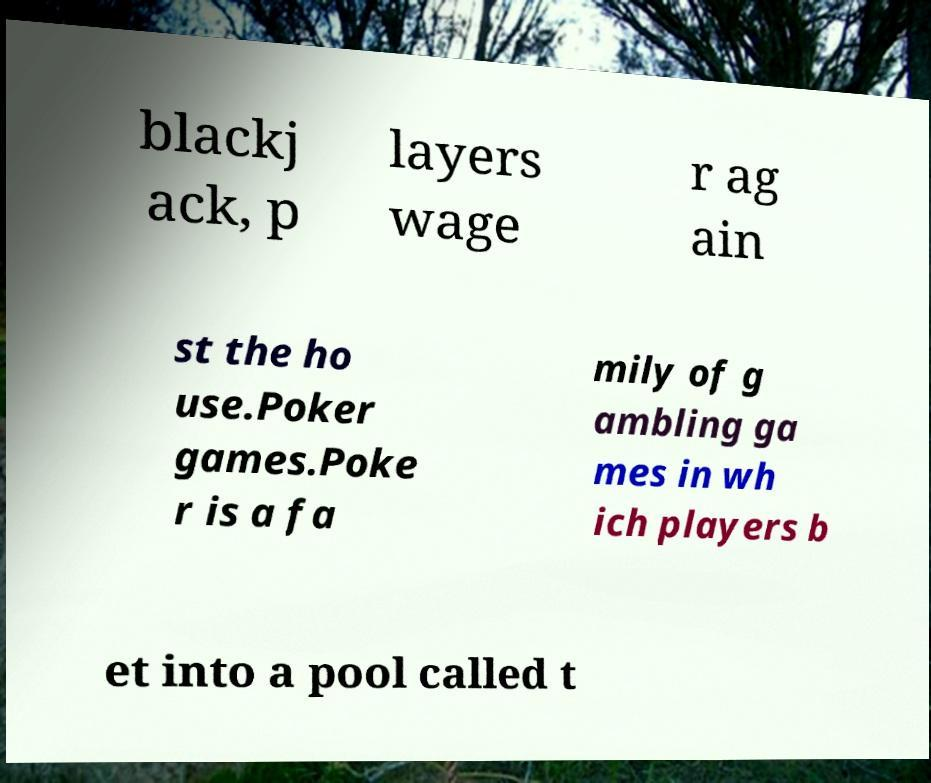Please identify and transcribe the text found in this image. blackj ack, p layers wage r ag ain st the ho use.Poker games.Poke r is a fa mily of g ambling ga mes in wh ich players b et into a pool called t 